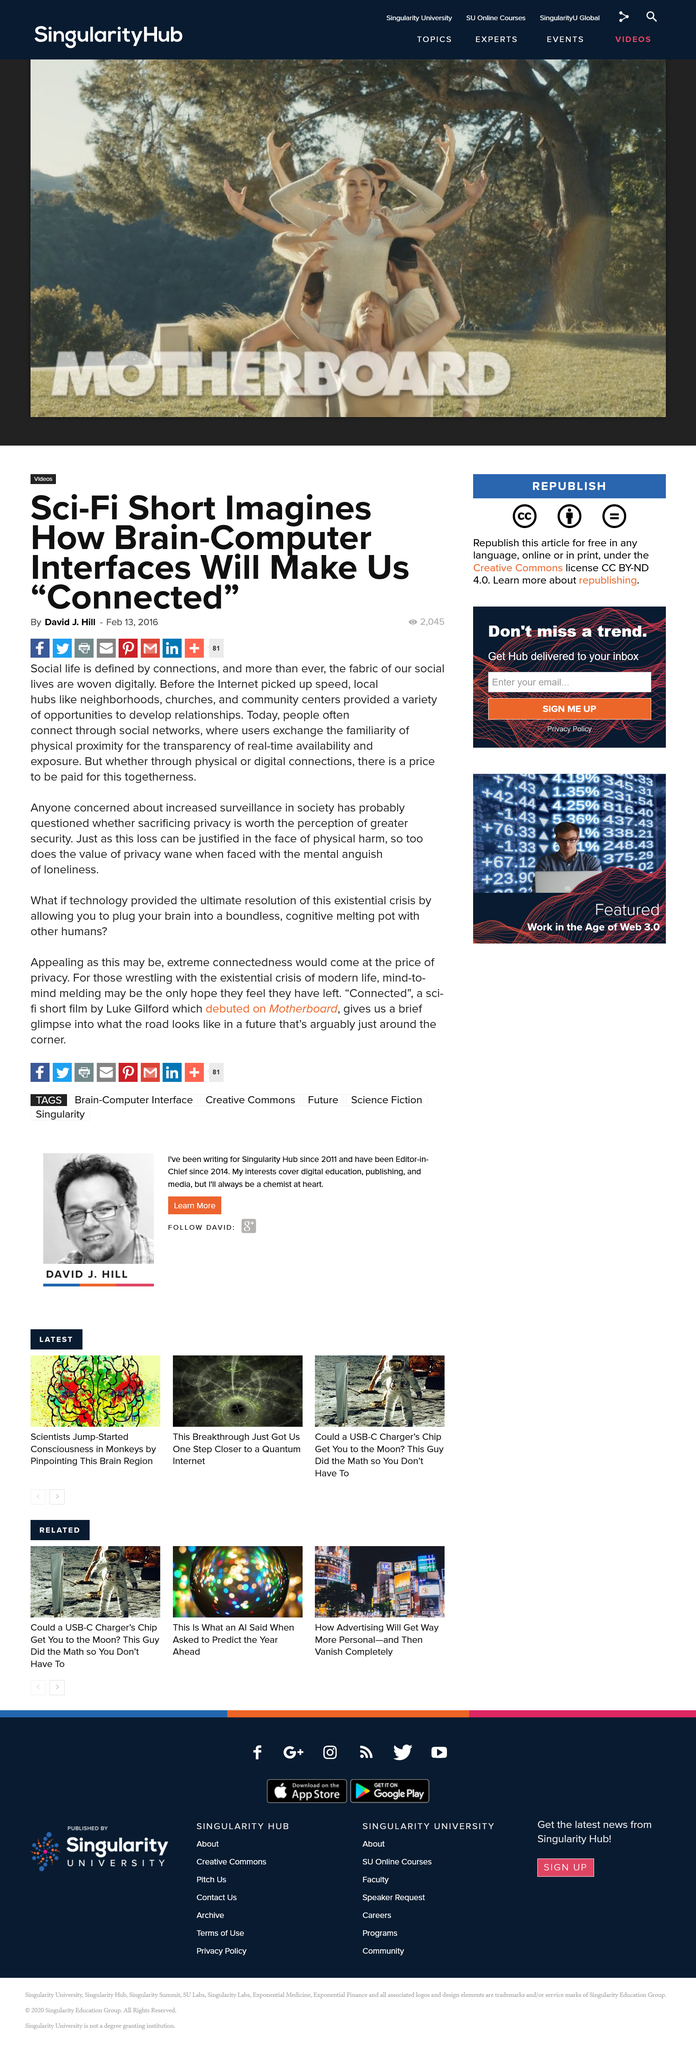Draw attention to some important aspects in this diagram. Churches are a local hub that is capable of creating a sense of community and belonging among its members and the surrounding area. Social life is defined by connections, as it is the relationships and interactions one has with others that shape and define one's experiences and overall well-being. The value of privacy wanes when faced with the mental anguish of loneliness. 